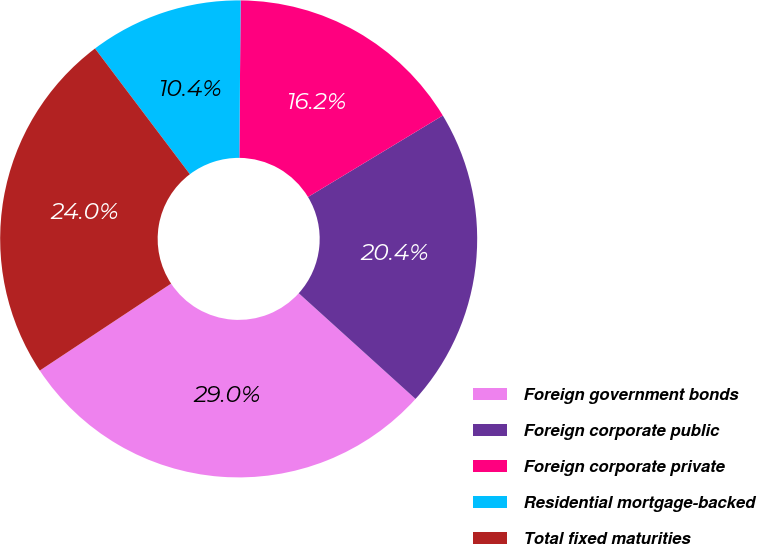Convert chart to OTSL. <chart><loc_0><loc_0><loc_500><loc_500><pie_chart><fcel>Foreign government bonds<fcel>Foreign corporate public<fcel>Foreign corporate private<fcel>Residential mortgage-backed<fcel>Total fixed maturities<nl><fcel>28.99%<fcel>20.36%<fcel>16.22%<fcel>10.42%<fcel>24.02%<nl></chart> 